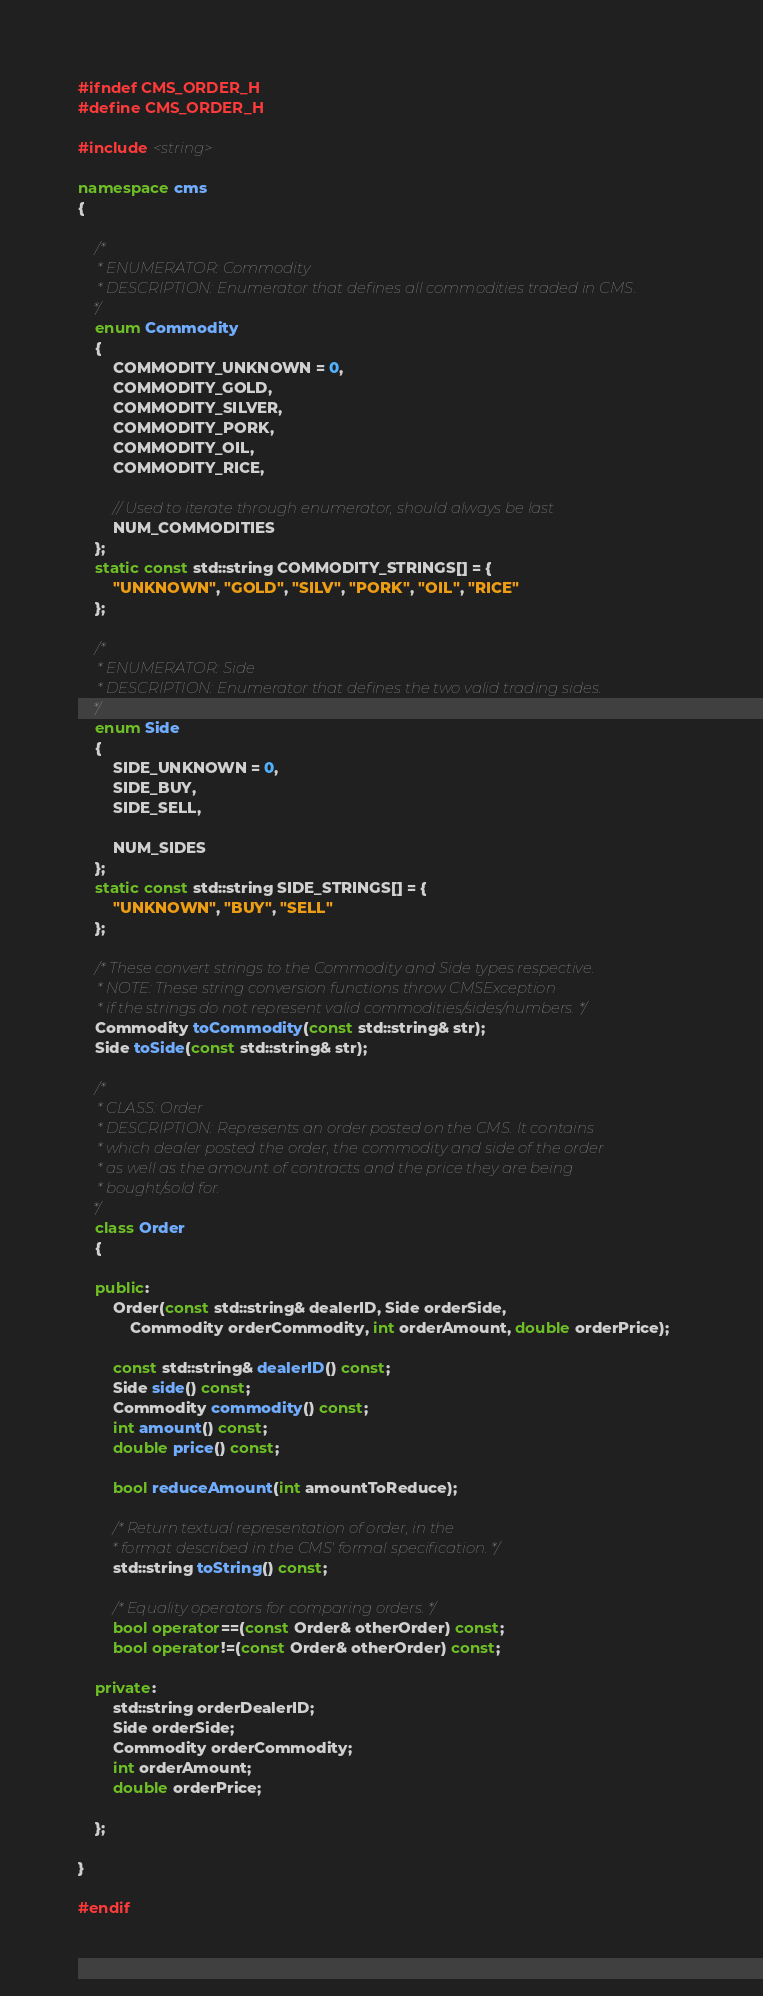Convert code to text. <code><loc_0><loc_0><loc_500><loc_500><_C++_>#ifndef CMS_ORDER_H
#define CMS_ORDER_H

#include <string>

namespace cms
{

	/*
	 * ENUMERATOR: Commodity
	 * DESCRIPTION: Enumerator that defines all commodities traded in CMS. 
	*/
	enum Commodity
	{
		COMMODITY_UNKNOWN = 0,
		COMMODITY_GOLD,
		COMMODITY_SILVER,
		COMMODITY_PORK,
		COMMODITY_OIL,
		COMMODITY_RICE,

		// Used to iterate through enumerator, should always be last
		NUM_COMMODITIES
	};
	static const std::string COMMODITY_STRINGS[] = {
		"UNKNOWN", "GOLD", "SILV", "PORK", "OIL", "RICE"
	};	

	/*
	 * ENUMERATOR: Side
	 * DESCRIPTION: Enumerator that defines the two valid trading sides.
	*/
	enum Side
	{
		SIDE_UNKNOWN = 0,
		SIDE_BUY,
		SIDE_SELL,

		NUM_SIDES
	};
	static const std::string SIDE_STRINGS[] = {
		"UNKNOWN", "BUY", "SELL" 
	};

	/* These convert strings to the Commodity and Side types respective.
	 * NOTE: These string conversion functions throw CMSException
	 * if the strings do not represent valid commodities/sides/numbers. */
	Commodity toCommodity(const std::string& str);
	Side toSide(const std::string& str);

	/*
	 * CLASS: Order
	 * DESCRIPTION: Represents an order posted on the CMS. It contains
	 * which dealer posted the order, the commodity and side of the order
	 * as well as the amount of contracts and the price they are being
	 * bought/sold for.
	*/
	class Order
	{

	public:
		Order(const std::string& dealerID, Side orderSide,
			Commodity orderCommodity, int orderAmount, double orderPrice);

		const std::string& dealerID() const;
		Side side() const;
		Commodity commodity() const;
		int amount() const;
		double price() const;

		bool reduceAmount(int amountToReduce);

		/* Return textual representation of order, in the
		 * format described in the CMS' formal specification. */
		std::string toString() const;

		/* Equality operators for comparing orders. */
		bool operator==(const Order& otherOrder) const;
		bool operator!=(const Order& otherOrder) const;

	private:
		std::string orderDealerID;
		Side orderSide;
		Commodity orderCommodity;
		int orderAmount;
		double orderPrice;

	};

}

#endif</code> 